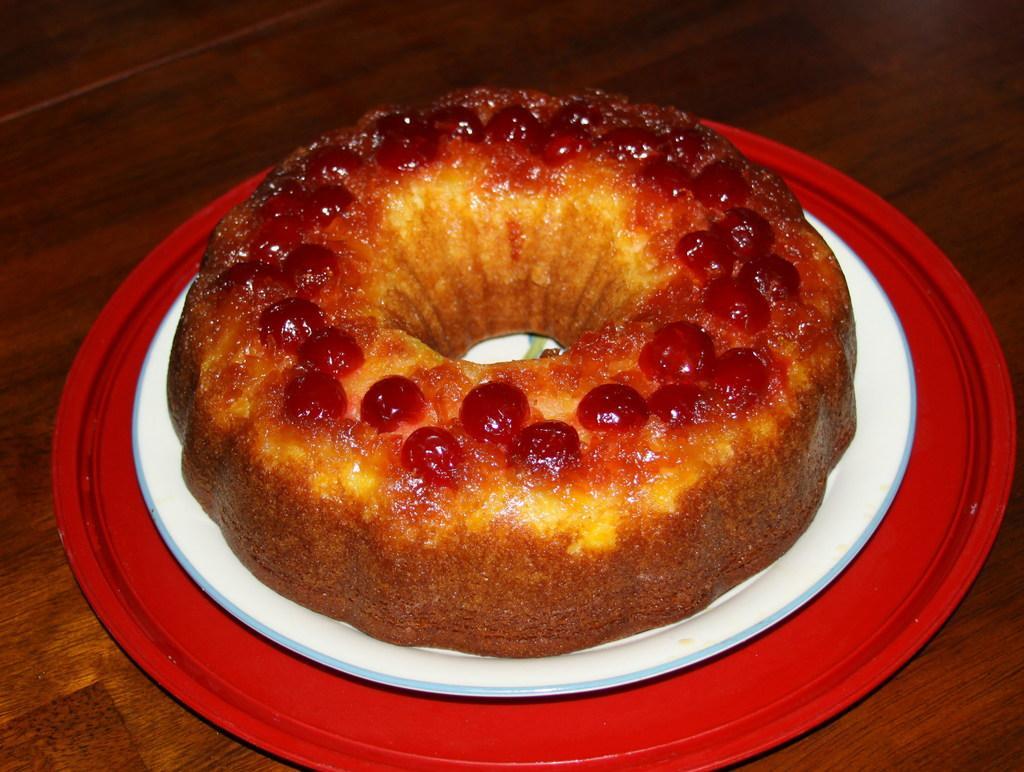Can you describe this image briefly? In this image we can see food placed on the table. 